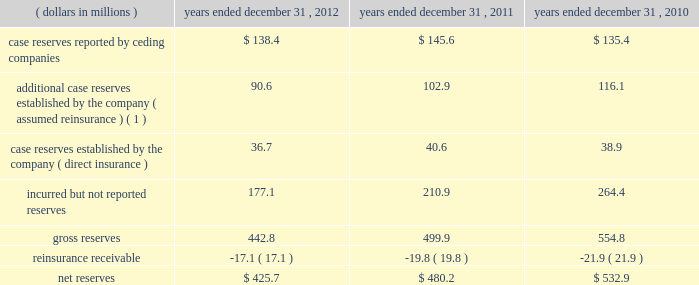The company endeavors to actively engage with every insured account posing significant potential asbestos exposure to mt .
Mckinley .
Such engagement can take the form of pursuing a final settlement , negotiation , litigation , or the monitoring of claim activity under settlement in place ( 201csip 201d ) agreements .
Sip agreements generally condition an insurer 2019s payment upon the actual claim experience of the insured and may have annual payment caps or other measures to control the insurer 2019s payments .
The company 2019s mt .
Mckinley operation is currently managing four sip agreements , one of which was executed prior to the acquisition of mt .
Mckinley in 2000 .
The company 2019s preference with respect to coverage settlements is to execute settlements that call for a fixed schedule of payments , because such settlements eliminate future uncertainty .
The company has significantly enhanced its classification of insureds by exposure characteristics over time , as well as its analysis by insured for those it considers to be more exposed or active .
Those insureds identified as relatively less exposed or active are subject to less rigorous , but still active management , with an emphasis on monitoring those characteristics , which may indicate an increasing exposure or levels of activity .
The company continually focuses on further enhancement of the detailed estimation processes used to evaluate potential exposure of policyholders .
Everest re 2019s book of assumed a&e reinsurance is relatively concentrated within a limited number of contracts and for a limited period , from 1974 to 1984 .
Because the book of business is relatively concentrated and the company has been managing the a&e exposures for many years , its claim staff is familiar with the ceding companies that have generated most of these liabilities in the past and which are therefore most likely to generate future liabilities .
The company 2019s claim staff has developed familiarity both with the nature of the business written by its ceding companies and the claims handling and reserving practices of those companies .
This level of familiarity enhances the quality of the company 2019s analysis of its exposure through those companies .
As a result , the company believes that it can identify those claims on which it has unusual exposure , such as non-products asbestos claims , for concentrated attention .
However , in setting reserves for its reinsurance liabilities , the company relies on claims data supplied , both formally and informally by its ceding companies and brokers .
This furnished information is not always timely or accurate and can impact the accuracy and timeliness of the company 2019s ultimate loss projections .
The table summarizes the composition of the company 2019s total reserves for a&e losses , gross and net of reinsurance , for the periods indicated: .
( 1 ) additional reserves are case specific reserves established by the company in excess of those reported by the ceding company , based on the company 2019s assessment of the covered loss .
( some amounts may not reconcile due to rounding. ) additional losses , including those relating to latent injuries and other exposures , which are as yet unrecognized , the type or magnitude of which cannot be foreseen by either the company or the industry , may emerge in the future .
Such future emergence could have material adverse effects on the company 2019s future financial condition , results of operations and cash flows. .
As of december 31 , 2012 what was the percentage change in net reserves from 2011? 
Rationale: to obtain the percent you get the change and divide it by the early amount
Computations: ((425.7 - 480.2) / 480.2)
Answer: -0.11349. 